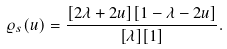Convert formula to latex. <formula><loc_0><loc_0><loc_500><loc_500>\varrho _ { s } ( u ) = \frac { [ 2 \lambda + 2 u ] [ 1 - \lambda - 2 u ] } { [ \lambda ] [ 1 ] } .</formula> 